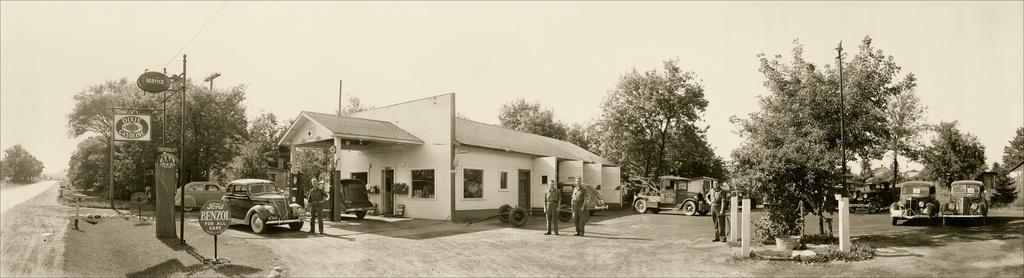What is the color scheme of the image? The image is black and white. What type of natural elements can be seen in the image? There are trees in the image. What type of man-made structures are present in the image? There are buildings in the image. What type of transportation is visible in the image? There are vehicles in the image. Are there any living beings present in the image? Yes, there are people in the image. What type of decorative element can be seen in the image? There is a potted plant in the image. What type of infrastructure is visible in the image? There are poles and wires in the image. What type of signage is present in the image? There are boards in the image, which could potentially have signage on them. What type of surface can vehicles be seen traveling on in the image? There is a road in the image. What is visible at the top of the image? The sky is visible at the top of the image. Can you describe the battle taking place in the image? There is no battle present in the image; it features a scene with trees, buildings, vehicles, people, a potted plant, poles, wires, boards, a road, and a black and white color scheme. 